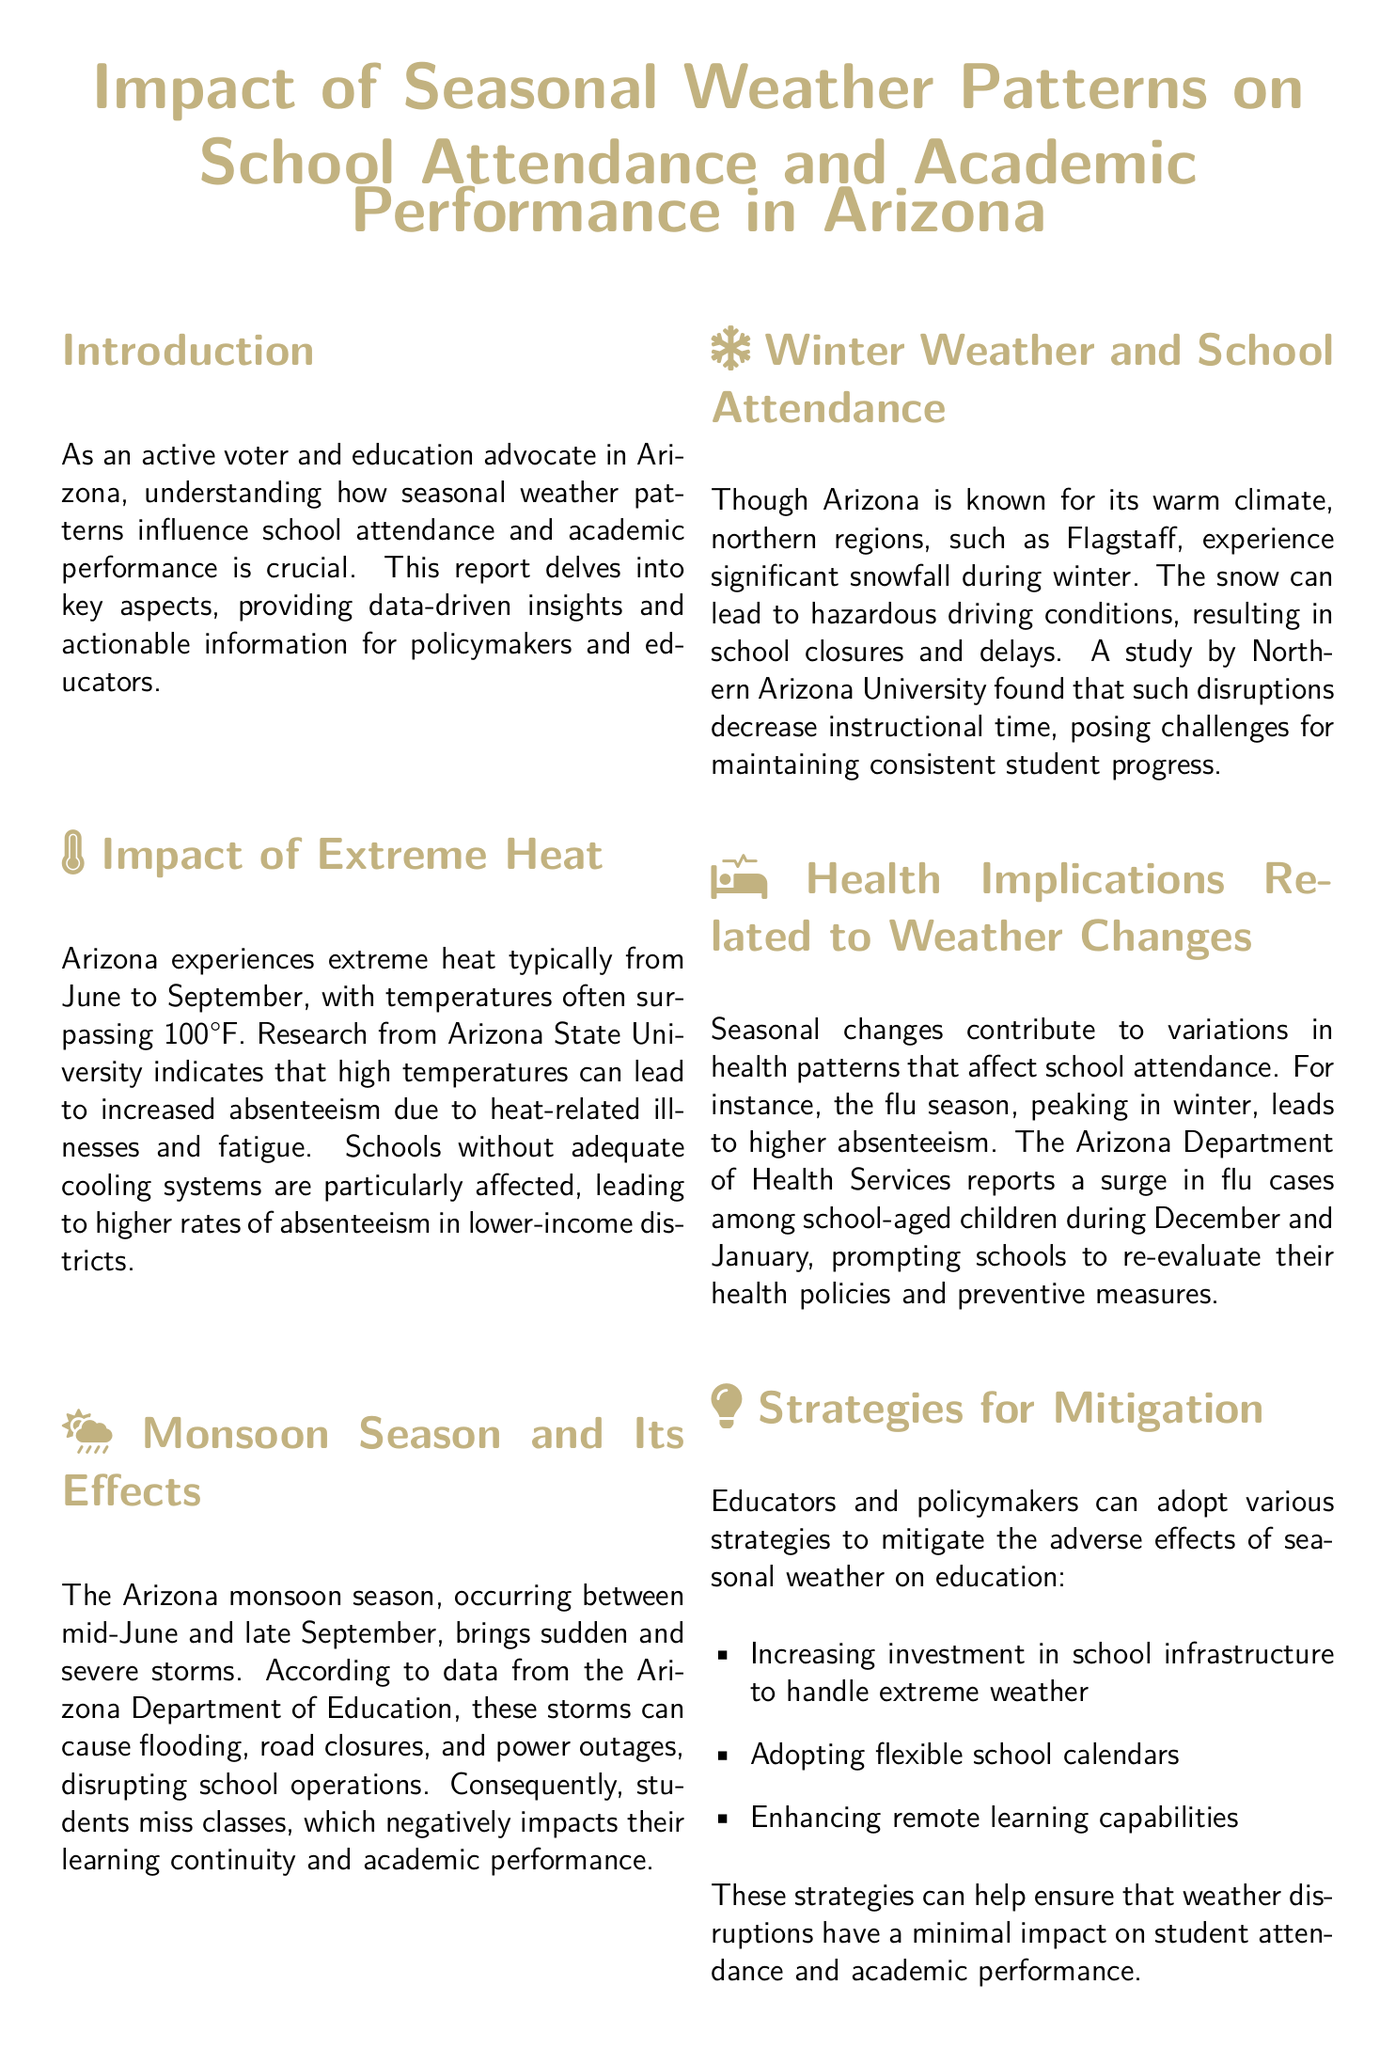What is the primary focus of this report? The report focuses on how seasonal weather patterns influence school attendance and academic performance in Arizona.
Answer: School attendance and academic performance During which months does the extreme heat occur in Arizona? The report states that extreme heat typically occurs from June to September.
Answer: June to September What health issue peaks in winter, affecting student absenteeism? The document mentions the flu season, which leads to higher absenteeism during winter months.
Answer: Flu season What can schools invest in to handle extreme weather better? One recommended strategy is increasing investment in school infrastructure to handle extreme weather.
Answer: School infrastructure What negative impact does the monsoon season have on schools? The monsoon season can cause flooding, road closures, and power outages, disrupting school operations.
Answer: Flooding, road closures, and power outages Which region of Arizona experiences significant snowfall in winter? The document identifies Flagstaff as the region that experiences significant snowfall during winter.
Answer: Flagstaff What is one of the strategies suggested for mitigating weather impacts? The document suggests adopting flexible school calendars as one of the strategies.
Answer: Flexible school calendars What does the Arizona Department of Education report regarding storms? The report indicates that storms during the monsoon season disrupt school operations.
Answer: Disrupt school operations 